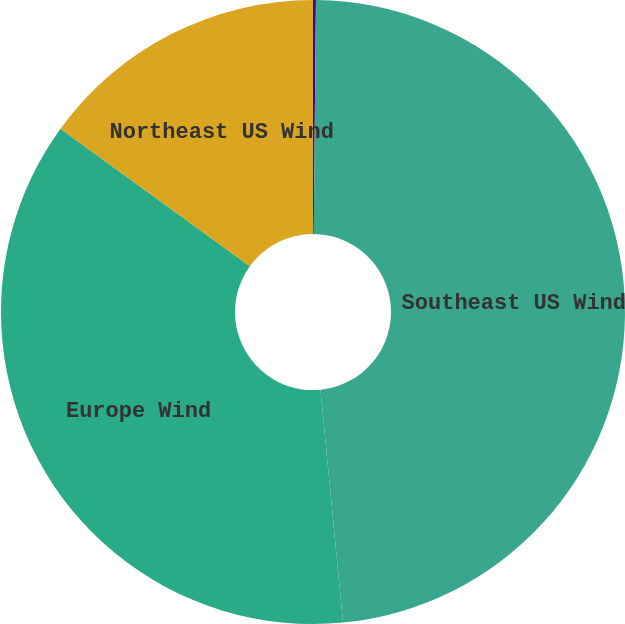Convert chart to OTSL. <chart><loc_0><loc_0><loc_500><loc_500><pie_chart><fcel>Exceeding Probability<fcel>Southeast US Wind<fcel>Europe Wind<fcel>Northeast US Wind<nl><fcel>0.15%<fcel>48.32%<fcel>36.53%<fcel>15.01%<nl></chart> 